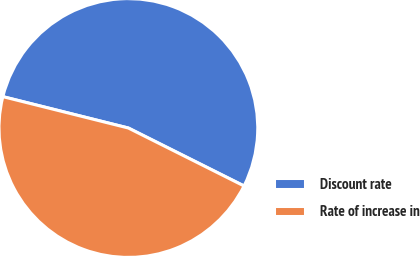<chart> <loc_0><loc_0><loc_500><loc_500><pie_chart><fcel>Discount rate<fcel>Rate of increase in<nl><fcel>53.49%<fcel>46.51%<nl></chart> 